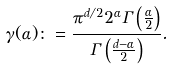Convert formula to latex. <formula><loc_0><loc_0><loc_500><loc_500>\gamma ( \alpha ) \colon = \frac { \pi ^ { d / 2 } 2 ^ { \alpha } \Gamma \left ( \frac { \alpha } { 2 } \right ) } { \Gamma \left ( \frac { d - \alpha } { 2 } \right ) } .</formula> 